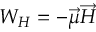Convert formula to latex. <formula><loc_0><loc_0><loc_500><loc_500>W _ { H } = - \overrightarrow { \mu } \overrightarrow { H }</formula> 